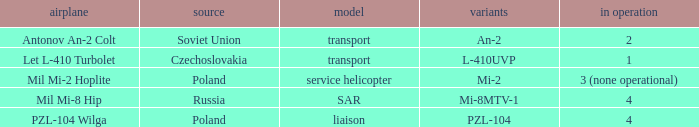Tell me the service for versions l-410uvp 1.0. 